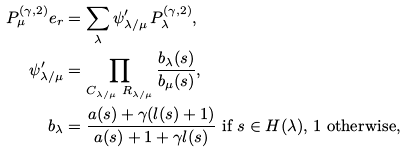Convert formula to latex. <formula><loc_0><loc_0><loc_500><loc_500>P ^ { ( \gamma , 2 ) } _ { \mu } e _ { r } & = \sum _ { \lambda } \psi ^ { \prime } _ { \lambda / \mu } \, P ^ { ( \gamma , 2 ) } _ { \lambda } , \\ \psi ^ { \prime } _ { \lambda / \mu } & = \prod _ { C _ { \lambda / \mu } \ R _ { \lambda / \mu } } \frac { b _ { \lambda } ( s ) } { b _ { \mu } ( s ) } , \\ b _ { \lambda } & = \frac { a ( s ) + \gamma ( l ( s ) + 1 ) } { a ( s ) + 1 + \gamma l ( s ) } \text { if } s \in H ( \lambda ) \text {, 1 otherwise} ,</formula> 